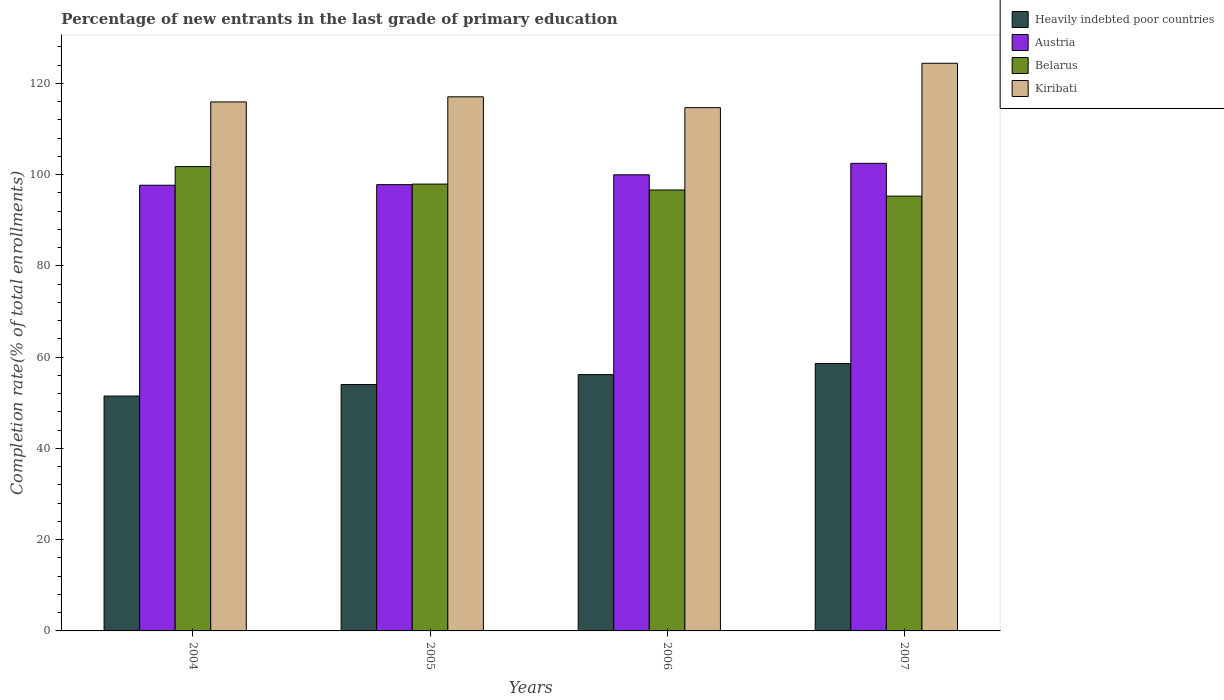How many different coloured bars are there?
Keep it short and to the point. 4. How many bars are there on the 2nd tick from the left?
Your response must be concise. 4. How many bars are there on the 3rd tick from the right?
Provide a short and direct response. 4. In how many cases, is the number of bars for a given year not equal to the number of legend labels?
Offer a terse response. 0. What is the percentage of new entrants in Austria in 2007?
Offer a very short reply. 102.5. Across all years, what is the maximum percentage of new entrants in Kiribati?
Make the answer very short. 124.43. Across all years, what is the minimum percentage of new entrants in Kiribati?
Provide a succinct answer. 114.7. In which year was the percentage of new entrants in Belarus maximum?
Your response must be concise. 2004. What is the total percentage of new entrants in Heavily indebted poor countries in the graph?
Offer a very short reply. 220.28. What is the difference between the percentage of new entrants in Belarus in 2006 and that in 2007?
Make the answer very short. 1.35. What is the difference between the percentage of new entrants in Belarus in 2005 and the percentage of new entrants in Austria in 2006?
Provide a succinct answer. -2.04. What is the average percentage of new entrants in Austria per year?
Give a very brief answer. 99.5. In the year 2007, what is the difference between the percentage of new entrants in Belarus and percentage of new entrants in Austria?
Your response must be concise. -7.19. In how many years, is the percentage of new entrants in Heavily indebted poor countries greater than 84 %?
Your response must be concise. 0. What is the ratio of the percentage of new entrants in Belarus in 2005 to that in 2006?
Provide a short and direct response. 1.01. Is the percentage of new entrants in Heavily indebted poor countries in 2004 less than that in 2006?
Offer a terse response. Yes. What is the difference between the highest and the second highest percentage of new entrants in Belarus?
Ensure brevity in your answer.  3.84. What is the difference between the highest and the lowest percentage of new entrants in Kiribati?
Provide a succinct answer. 9.74. In how many years, is the percentage of new entrants in Belarus greater than the average percentage of new entrants in Belarus taken over all years?
Provide a succinct answer. 2. Is the sum of the percentage of new entrants in Heavily indebted poor countries in 2006 and 2007 greater than the maximum percentage of new entrants in Belarus across all years?
Make the answer very short. Yes. What does the 3rd bar from the right in 2006 represents?
Provide a succinct answer. Austria. How many bars are there?
Make the answer very short. 16. Are all the bars in the graph horizontal?
Give a very brief answer. No. Are the values on the major ticks of Y-axis written in scientific E-notation?
Your response must be concise. No. Does the graph contain any zero values?
Provide a short and direct response. No. Does the graph contain grids?
Keep it short and to the point. No. How are the legend labels stacked?
Provide a short and direct response. Vertical. What is the title of the graph?
Your answer should be very brief. Percentage of new entrants in the last grade of primary education. Does "Serbia" appear as one of the legend labels in the graph?
Provide a short and direct response. No. What is the label or title of the X-axis?
Offer a very short reply. Years. What is the label or title of the Y-axis?
Your response must be concise. Completion rate(% of total enrollments). What is the Completion rate(% of total enrollments) in Heavily indebted poor countries in 2004?
Your response must be concise. 51.49. What is the Completion rate(% of total enrollments) in Austria in 2004?
Ensure brevity in your answer.  97.7. What is the Completion rate(% of total enrollments) in Belarus in 2004?
Keep it short and to the point. 101.79. What is the Completion rate(% of total enrollments) in Kiribati in 2004?
Make the answer very short. 115.96. What is the Completion rate(% of total enrollments) in Heavily indebted poor countries in 2005?
Offer a terse response. 54. What is the Completion rate(% of total enrollments) of Austria in 2005?
Offer a terse response. 97.82. What is the Completion rate(% of total enrollments) in Belarus in 2005?
Make the answer very short. 97.95. What is the Completion rate(% of total enrollments) of Kiribati in 2005?
Your response must be concise. 117.08. What is the Completion rate(% of total enrollments) in Heavily indebted poor countries in 2006?
Keep it short and to the point. 56.18. What is the Completion rate(% of total enrollments) of Austria in 2006?
Your answer should be very brief. 99.98. What is the Completion rate(% of total enrollments) of Belarus in 2006?
Provide a short and direct response. 96.65. What is the Completion rate(% of total enrollments) of Kiribati in 2006?
Give a very brief answer. 114.7. What is the Completion rate(% of total enrollments) in Heavily indebted poor countries in 2007?
Keep it short and to the point. 58.61. What is the Completion rate(% of total enrollments) in Austria in 2007?
Keep it short and to the point. 102.5. What is the Completion rate(% of total enrollments) in Belarus in 2007?
Give a very brief answer. 95.31. What is the Completion rate(% of total enrollments) of Kiribati in 2007?
Keep it short and to the point. 124.43. Across all years, what is the maximum Completion rate(% of total enrollments) of Heavily indebted poor countries?
Your answer should be very brief. 58.61. Across all years, what is the maximum Completion rate(% of total enrollments) in Austria?
Provide a succinct answer. 102.5. Across all years, what is the maximum Completion rate(% of total enrollments) of Belarus?
Make the answer very short. 101.79. Across all years, what is the maximum Completion rate(% of total enrollments) of Kiribati?
Keep it short and to the point. 124.43. Across all years, what is the minimum Completion rate(% of total enrollments) of Heavily indebted poor countries?
Keep it short and to the point. 51.49. Across all years, what is the minimum Completion rate(% of total enrollments) of Austria?
Give a very brief answer. 97.7. Across all years, what is the minimum Completion rate(% of total enrollments) of Belarus?
Your answer should be compact. 95.31. Across all years, what is the minimum Completion rate(% of total enrollments) in Kiribati?
Offer a terse response. 114.7. What is the total Completion rate(% of total enrollments) in Heavily indebted poor countries in the graph?
Make the answer very short. 220.28. What is the total Completion rate(% of total enrollments) of Austria in the graph?
Give a very brief answer. 398.01. What is the total Completion rate(% of total enrollments) of Belarus in the graph?
Give a very brief answer. 391.7. What is the total Completion rate(% of total enrollments) of Kiribati in the graph?
Offer a very short reply. 472.17. What is the difference between the Completion rate(% of total enrollments) of Heavily indebted poor countries in 2004 and that in 2005?
Provide a succinct answer. -2.52. What is the difference between the Completion rate(% of total enrollments) of Austria in 2004 and that in 2005?
Offer a terse response. -0.13. What is the difference between the Completion rate(% of total enrollments) in Belarus in 2004 and that in 2005?
Your answer should be very brief. 3.84. What is the difference between the Completion rate(% of total enrollments) of Kiribati in 2004 and that in 2005?
Ensure brevity in your answer.  -1.12. What is the difference between the Completion rate(% of total enrollments) of Heavily indebted poor countries in 2004 and that in 2006?
Provide a short and direct response. -4.7. What is the difference between the Completion rate(% of total enrollments) of Austria in 2004 and that in 2006?
Your answer should be very brief. -2.29. What is the difference between the Completion rate(% of total enrollments) in Belarus in 2004 and that in 2006?
Provide a succinct answer. 5.13. What is the difference between the Completion rate(% of total enrollments) in Kiribati in 2004 and that in 2006?
Offer a very short reply. 1.26. What is the difference between the Completion rate(% of total enrollments) of Heavily indebted poor countries in 2004 and that in 2007?
Offer a terse response. -7.12. What is the difference between the Completion rate(% of total enrollments) in Austria in 2004 and that in 2007?
Provide a succinct answer. -4.8. What is the difference between the Completion rate(% of total enrollments) of Belarus in 2004 and that in 2007?
Ensure brevity in your answer.  6.48. What is the difference between the Completion rate(% of total enrollments) in Kiribati in 2004 and that in 2007?
Provide a succinct answer. -8.48. What is the difference between the Completion rate(% of total enrollments) of Heavily indebted poor countries in 2005 and that in 2006?
Provide a short and direct response. -2.18. What is the difference between the Completion rate(% of total enrollments) in Austria in 2005 and that in 2006?
Provide a short and direct response. -2.16. What is the difference between the Completion rate(% of total enrollments) in Belarus in 2005 and that in 2006?
Offer a terse response. 1.29. What is the difference between the Completion rate(% of total enrollments) of Kiribati in 2005 and that in 2006?
Your answer should be compact. 2.38. What is the difference between the Completion rate(% of total enrollments) of Heavily indebted poor countries in 2005 and that in 2007?
Keep it short and to the point. -4.6. What is the difference between the Completion rate(% of total enrollments) of Austria in 2005 and that in 2007?
Offer a very short reply. -4.68. What is the difference between the Completion rate(% of total enrollments) of Belarus in 2005 and that in 2007?
Your answer should be very brief. 2.64. What is the difference between the Completion rate(% of total enrollments) in Kiribati in 2005 and that in 2007?
Keep it short and to the point. -7.36. What is the difference between the Completion rate(% of total enrollments) of Heavily indebted poor countries in 2006 and that in 2007?
Your response must be concise. -2.42. What is the difference between the Completion rate(% of total enrollments) in Austria in 2006 and that in 2007?
Your answer should be very brief. -2.52. What is the difference between the Completion rate(% of total enrollments) in Belarus in 2006 and that in 2007?
Provide a succinct answer. 1.35. What is the difference between the Completion rate(% of total enrollments) of Kiribati in 2006 and that in 2007?
Offer a very short reply. -9.74. What is the difference between the Completion rate(% of total enrollments) of Heavily indebted poor countries in 2004 and the Completion rate(% of total enrollments) of Austria in 2005?
Your answer should be very brief. -46.34. What is the difference between the Completion rate(% of total enrollments) of Heavily indebted poor countries in 2004 and the Completion rate(% of total enrollments) of Belarus in 2005?
Keep it short and to the point. -46.46. What is the difference between the Completion rate(% of total enrollments) of Heavily indebted poor countries in 2004 and the Completion rate(% of total enrollments) of Kiribati in 2005?
Your answer should be compact. -65.59. What is the difference between the Completion rate(% of total enrollments) in Austria in 2004 and the Completion rate(% of total enrollments) in Belarus in 2005?
Offer a very short reply. -0.25. What is the difference between the Completion rate(% of total enrollments) in Austria in 2004 and the Completion rate(% of total enrollments) in Kiribati in 2005?
Your answer should be very brief. -19.38. What is the difference between the Completion rate(% of total enrollments) in Belarus in 2004 and the Completion rate(% of total enrollments) in Kiribati in 2005?
Provide a succinct answer. -15.29. What is the difference between the Completion rate(% of total enrollments) of Heavily indebted poor countries in 2004 and the Completion rate(% of total enrollments) of Austria in 2006?
Provide a succinct answer. -48.5. What is the difference between the Completion rate(% of total enrollments) of Heavily indebted poor countries in 2004 and the Completion rate(% of total enrollments) of Belarus in 2006?
Give a very brief answer. -45.17. What is the difference between the Completion rate(% of total enrollments) of Heavily indebted poor countries in 2004 and the Completion rate(% of total enrollments) of Kiribati in 2006?
Give a very brief answer. -63.21. What is the difference between the Completion rate(% of total enrollments) of Austria in 2004 and the Completion rate(% of total enrollments) of Belarus in 2006?
Keep it short and to the point. 1.04. What is the difference between the Completion rate(% of total enrollments) of Austria in 2004 and the Completion rate(% of total enrollments) of Kiribati in 2006?
Give a very brief answer. -17. What is the difference between the Completion rate(% of total enrollments) in Belarus in 2004 and the Completion rate(% of total enrollments) in Kiribati in 2006?
Offer a terse response. -12.91. What is the difference between the Completion rate(% of total enrollments) of Heavily indebted poor countries in 2004 and the Completion rate(% of total enrollments) of Austria in 2007?
Offer a very short reply. -51.01. What is the difference between the Completion rate(% of total enrollments) in Heavily indebted poor countries in 2004 and the Completion rate(% of total enrollments) in Belarus in 2007?
Offer a very short reply. -43.82. What is the difference between the Completion rate(% of total enrollments) of Heavily indebted poor countries in 2004 and the Completion rate(% of total enrollments) of Kiribati in 2007?
Keep it short and to the point. -72.95. What is the difference between the Completion rate(% of total enrollments) of Austria in 2004 and the Completion rate(% of total enrollments) of Belarus in 2007?
Your response must be concise. 2.39. What is the difference between the Completion rate(% of total enrollments) of Austria in 2004 and the Completion rate(% of total enrollments) of Kiribati in 2007?
Provide a succinct answer. -26.74. What is the difference between the Completion rate(% of total enrollments) in Belarus in 2004 and the Completion rate(% of total enrollments) in Kiribati in 2007?
Your answer should be compact. -22.65. What is the difference between the Completion rate(% of total enrollments) of Heavily indebted poor countries in 2005 and the Completion rate(% of total enrollments) of Austria in 2006?
Offer a terse response. -45.98. What is the difference between the Completion rate(% of total enrollments) of Heavily indebted poor countries in 2005 and the Completion rate(% of total enrollments) of Belarus in 2006?
Keep it short and to the point. -42.65. What is the difference between the Completion rate(% of total enrollments) of Heavily indebted poor countries in 2005 and the Completion rate(% of total enrollments) of Kiribati in 2006?
Offer a very short reply. -60.69. What is the difference between the Completion rate(% of total enrollments) in Austria in 2005 and the Completion rate(% of total enrollments) in Belarus in 2006?
Provide a succinct answer. 1.17. What is the difference between the Completion rate(% of total enrollments) in Austria in 2005 and the Completion rate(% of total enrollments) in Kiribati in 2006?
Provide a short and direct response. -16.87. What is the difference between the Completion rate(% of total enrollments) in Belarus in 2005 and the Completion rate(% of total enrollments) in Kiribati in 2006?
Provide a short and direct response. -16.75. What is the difference between the Completion rate(% of total enrollments) in Heavily indebted poor countries in 2005 and the Completion rate(% of total enrollments) in Austria in 2007?
Give a very brief answer. -48.5. What is the difference between the Completion rate(% of total enrollments) in Heavily indebted poor countries in 2005 and the Completion rate(% of total enrollments) in Belarus in 2007?
Provide a short and direct response. -41.3. What is the difference between the Completion rate(% of total enrollments) in Heavily indebted poor countries in 2005 and the Completion rate(% of total enrollments) in Kiribati in 2007?
Make the answer very short. -70.43. What is the difference between the Completion rate(% of total enrollments) of Austria in 2005 and the Completion rate(% of total enrollments) of Belarus in 2007?
Provide a short and direct response. 2.52. What is the difference between the Completion rate(% of total enrollments) in Austria in 2005 and the Completion rate(% of total enrollments) in Kiribati in 2007?
Your response must be concise. -26.61. What is the difference between the Completion rate(% of total enrollments) in Belarus in 2005 and the Completion rate(% of total enrollments) in Kiribati in 2007?
Offer a terse response. -26.49. What is the difference between the Completion rate(% of total enrollments) in Heavily indebted poor countries in 2006 and the Completion rate(% of total enrollments) in Austria in 2007?
Ensure brevity in your answer.  -46.32. What is the difference between the Completion rate(% of total enrollments) in Heavily indebted poor countries in 2006 and the Completion rate(% of total enrollments) in Belarus in 2007?
Offer a very short reply. -39.13. What is the difference between the Completion rate(% of total enrollments) in Heavily indebted poor countries in 2006 and the Completion rate(% of total enrollments) in Kiribati in 2007?
Give a very brief answer. -68.25. What is the difference between the Completion rate(% of total enrollments) of Austria in 2006 and the Completion rate(% of total enrollments) of Belarus in 2007?
Your response must be concise. 4.68. What is the difference between the Completion rate(% of total enrollments) in Austria in 2006 and the Completion rate(% of total enrollments) in Kiribati in 2007?
Your response must be concise. -24.45. What is the difference between the Completion rate(% of total enrollments) in Belarus in 2006 and the Completion rate(% of total enrollments) in Kiribati in 2007?
Your answer should be very brief. -27.78. What is the average Completion rate(% of total enrollments) in Heavily indebted poor countries per year?
Make the answer very short. 55.07. What is the average Completion rate(% of total enrollments) of Austria per year?
Make the answer very short. 99.5. What is the average Completion rate(% of total enrollments) of Belarus per year?
Provide a short and direct response. 97.92. What is the average Completion rate(% of total enrollments) in Kiribati per year?
Your answer should be very brief. 118.04. In the year 2004, what is the difference between the Completion rate(% of total enrollments) of Heavily indebted poor countries and Completion rate(% of total enrollments) of Austria?
Give a very brief answer. -46.21. In the year 2004, what is the difference between the Completion rate(% of total enrollments) of Heavily indebted poor countries and Completion rate(% of total enrollments) of Belarus?
Keep it short and to the point. -50.3. In the year 2004, what is the difference between the Completion rate(% of total enrollments) in Heavily indebted poor countries and Completion rate(% of total enrollments) in Kiribati?
Ensure brevity in your answer.  -64.47. In the year 2004, what is the difference between the Completion rate(% of total enrollments) in Austria and Completion rate(% of total enrollments) in Belarus?
Make the answer very short. -4.09. In the year 2004, what is the difference between the Completion rate(% of total enrollments) in Austria and Completion rate(% of total enrollments) in Kiribati?
Offer a terse response. -18.26. In the year 2004, what is the difference between the Completion rate(% of total enrollments) of Belarus and Completion rate(% of total enrollments) of Kiribati?
Provide a succinct answer. -14.17. In the year 2005, what is the difference between the Completion rate(% of total enrollments) of Heavily indebted poor countries and Completion rate(% of total enrollments) of Austria?
Your response must be concise. -43.82. In the year 2005, what is the difference between the Completion rate(% of total enrollments) of Heavily indebted poor countries and Completion rate(% of total enrollments) of Belarus?
Offer a terse response. -43.94. In the year 2005, what is the difference between the Completion rate(% of total enrollments) of Heavily indebted poor countries and Completion rate(% of total enrollments) of Kiribati?
Your answer should be very brief. -63.07. In the year 2005, what is the difference between the Completion rate(% of total enrollments) in Austria and Completion rate(% of total enrollments) in Belarus?
Provide a short and direct response. -0.12. In the year 2005, what is the difference between the Completion rate(% of total enrollments) in Austria and Completion rate(% of total enrollments) in Kiribati?
Ensure brevity in your answer.  -19.25. In the year 2005, what is the difference between the Completion rate(% of total enrollments) in Belarus and Completion rate(% of total enrollments) in Kiribati?
Your answer should be compact. -19.13. In the year 2006, what is the difference between the Completion rate(% of total enrollments) of Heavily indebted poor countries and Completion rate(% of total enrollments) of Austria?
Offer a terse response. -43.8. In the year 2006, what is the difference between the Completion rate(% of total enrollments) in Heavily indebted poor countries and Completion rate(% of total enrollments) in Belarus?
Offer a terse response. -40.47. In the year 2006, what is the difference between the Completion rate(% of total enrollments) of Heavily indebted poor countries and Completion rate(% of total enrollments) of Kiribati?
Provide a short and direct response. -58.51. In the year 2006, what is the difference between the Completion rate(% of total enrollments) of Austria and Completion rate(% of total enrollments) of Belarus?
Keep it short and to the point. 3.33. In the year 2006, what is the difference between the Completion rate(% of total enrollments) in Austria and Completion rate(% of total enrollments) in Kiribati?
Offer a very short reply. -14.71. In the year 2006, what is the difference between the Completion rate(% of total enrollments) of Belarus and Completion rate(% of total enrollments) of Kiribati?
Make the answer very short. -18.04. In the year 2007, what is the difference between the Completion rate(% of total enrollments) of Heavily indebted poor countries and Completion rate(% of total enrollments) of Austria?
Provide a succinct answer. -43.89. In the year 2007, what is the difference between the Completion rate(% of total enrollments) of Heavily indebted poor countries and Completion rate(% of total enrollments) of Belarus?
Your answer should be compact. -36.7. In the year 2007, what is the difference between the Completion rate(% of total enrollments) in Heavily indebted poor countries and Completion rate(% of total enrollments) in Kiribati?
Your answer should be very brief. -65.83. In the year 2007, what is the difference between the Completion rate(% of total enrollments) of Austria and Completion rate(% of total enrollments) of Belarus?
Give a very brief answer. 7.19. In the year 2007, what is the difference between the Completion rate(% of total enrollments) of Austria and Completion rate(% of total enrollments) of Kiribati?
Offer a terse response. -21.93. In the year 2007, what is the difference between the Completion rate(% of total enrollments) of Belarus and Completion rate(% of total enrollments) of Kiribati?
Give a very brief answer. -29.13. What is the ratio of the Completion rate(% of total enrollments) of Heavily indebted poor countries in 2004 to that in 2005?
Keep it short and to the point. 0.95. What is the ratio of the Completion rate(% of total enrollments) of Austria in 2004 to that in 2005?
Keep it short and to the point. 1. What is the ratio of the Completion rate(% of total enrollments) in Belarus in 2004 to that in 2005?
Your answer should be very brief. 1.04. What is the ratio of the Completion rate(% of total enrollments) in Heavily indebted poor countries in 2004 to that in 2006?
Keep it short and to the point. 0.92. What is the ratio of the Completion rate(% of total enrollments) of Austria in 2004 to that in 2006?
Your answer should be compact. 0.98. What is the ratio of the Completion rate(% of total enrollments) of Belarus in 2004 to that in 2006?
Your answer should be compact. 1.05. What is the ratio of the Completion rate(% of total enrollments) of Heavily indebted poor countries in 2004 to that in 2007?
Ensure brevity in your answer.  0.88. What is the ratio of the Completion rate(% of total enrollments) of Austria in 2004 to that in 2007?
Give a very brief answer. 0.95. What is the ratio of the Completion rate(% of total enrollments) in Belarus in 2004 to that in 2007?
Ensure brevity in your answer.  1.07. What is the ratio of the Completion rate(% of total enrollments) in Kiribati in 2004 to that in 2007?
Your answer should be compact. 0.93. What is the ratio of the Completion rate(% of total enrollments) of Heavily indebted poor countries in 2005 to that in 2006?
Offer a terse response. 0.96. What is the ratio of the Completion rate(% of total enrollments) in Austria in 2005 to that in 2006?
Your answer should be very brief. 0.98. What is the ratio of the Completion rate(% of total enrollments) in Belarus in 2005 to that in 2006?
Ensure brevity in your answer.  1.01. What is the ratio of the Completion rate(% of total enrollments) of Kiribati in 2005 to that in 2006?
Provide a succinct answer. 1.02. What is the ratio of the Completion rate(% of total enrollments) in Heavily indebted poor countries in 2005 to that in 2007?
Offer a very short reply. 0.92. What is the ratio of the Completion rate(% of total enrollments) of Austria in 2005 to that in 2007?
Give a very brief answer. 0.95. What is the ratio of the Completion rate(% of total enrollments) in Belarus in 2005 to that in 2007?
Give a very brief answer. 1.03. What is the ratio of the Completion rate(% of total enrollments) of Kiribati in 2005 to that in 2007?
Keep it short and to the point. 0.94. What is the ratio of the Completion rate(% of total enrollments) in Heavily indebted poor countries in 2006 to that in 2007?
Your answer should be compact. 0.96. What is the ratio of the Completion rate(% of total enrollments) of Austria in 2006 to that in 2007?
Provide a succinct answer. 0.98. What is the ratio of the Completion rate(% of total enrollments) in Belarus in 2006 to that in 2007?
Your answer should be very brief. 1.01. What is the ratio of the Completion rate(% of total enrollments) in Kiribati in 2006 to that in 2007?
Your response must be concise. 0.92. What is the difference between the highest and the second highest Completion rate(% of total enrollments) in Heavily indebted poor countries?
Ensure brevity in your answer.  2.42. What is the difference between the highest and the second highest Completion rate(% of total enrollments) of Austria?
Your answer should be compact. 2.52. What is the difference between the highest and the second highest Completion rate(% of total enrollments) of Belarus?
Your answer should be very brief. 3.84. What is the difference between the highest and the second highest Completion rate(% of total enrollments) of Kiribati?
Offer a terse response. 7.36. What is the difference between the highest and the lowest Completion rate(% of total enrollments) in Heavily indebted poor countries?
Provide a short and direct response. 7.12. What is the difference between the highest and the lowest Completion rate(% of total enrollments) in Austria?
Make the answer very short. 4.8. What is the difference between the highest and the lowest Completion rate(% of total enrollments) of Belarus?
Make the answer very short. 6.48. What is the difference between the highest and the lowest Completion rate(% of total enrollments) of Kiribati?
Give a very brief answer. 9.74. 